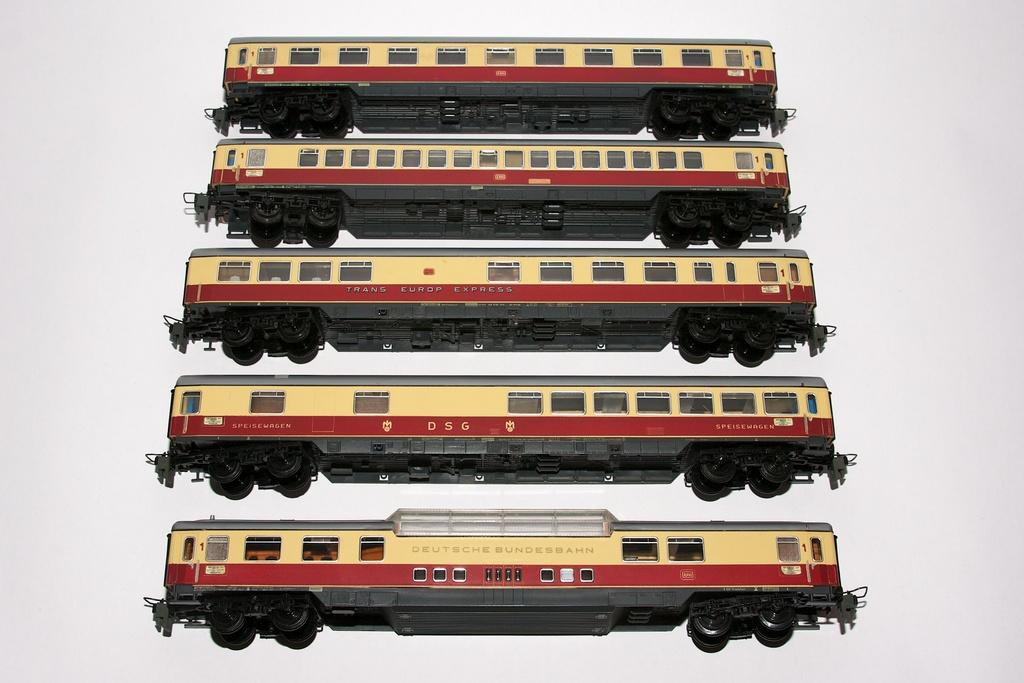What type of toy vehicles are present in the image? There are toy buses in the image. Can you describe the appearance of the toy buses? The toy buses are depicted in the image, but their specific appearance cannot be determined from the provided facts. Are there any other toy vehicles or objects present in the image? The facts provided only mention toy buses, so no other toy vehicles or objects can be confirmed. What holiday is being celebrated in the image? There is no information provided about a holiday being celebrated in the image. How many toy buses are shown falling in the image? There is no mention of toy buses falling in the image, and the facts provided do not indicate any such action. 